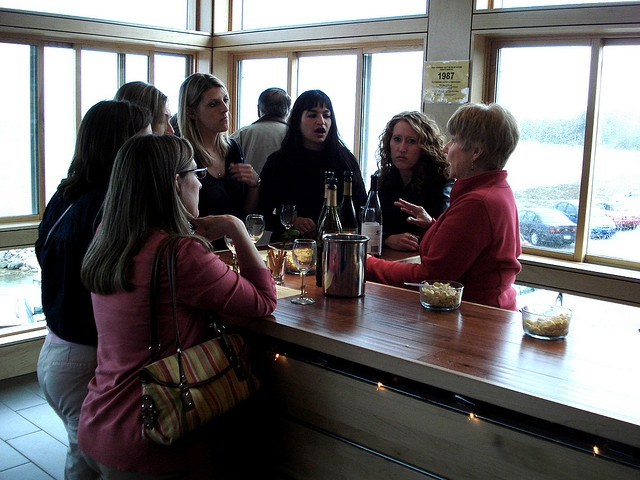Describe the objects in this image and their specific colors. I can see people in ivory, black, maroon, gray, and purple tones, people in ivory, black, gray, and blue tones, people in white, black, maroon, and gray tones, handbag in ivory, black, maroon, darkgreen, and gray tones, and people in ivory, black, maroon, gray, and navy tones in this image. 